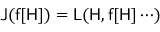<formula> <loc_0><loc_0><loc_500><loc_500>J ( f [ H ] ) = L ( H , f [ H ] \cdots )</formula> 